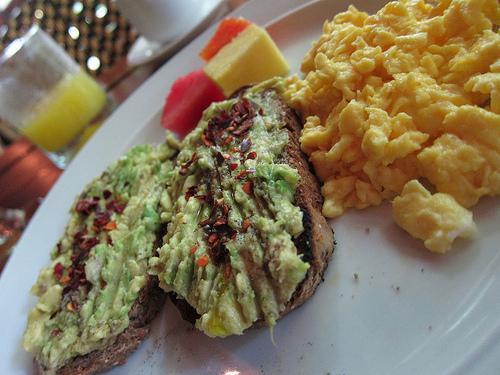How many plates are visible?
Give a very brief answer. 1. 